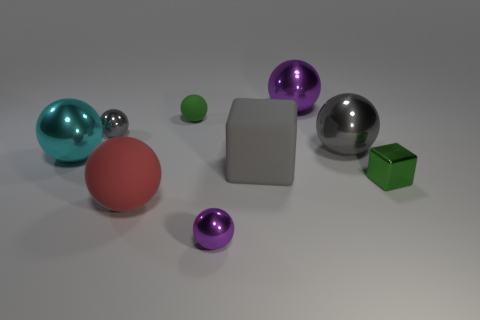Subtract all purple cylinders. How many gray balls are left? 2 Subtract all green balls. How many balls are left? 6 Subtract all tiny gray shiny spheres. How many spheres are left? 6 Subtract 1 balls. How many balls are left? 6 Add 1 big red balls. How many objects exist? 10 Subtract all green balls. Subtract all brown blocks. How many balls are left? 6 Subtract all blocks. How many objects are left? 7 Subtract 1 gray blocks. How many objects are left? 8 Subtract all large gray things. Subtract all tiny spheres. How many objects are left? 4 Add 9 tiny green rubber objects. How many tiny green rubber objects are left? 10 